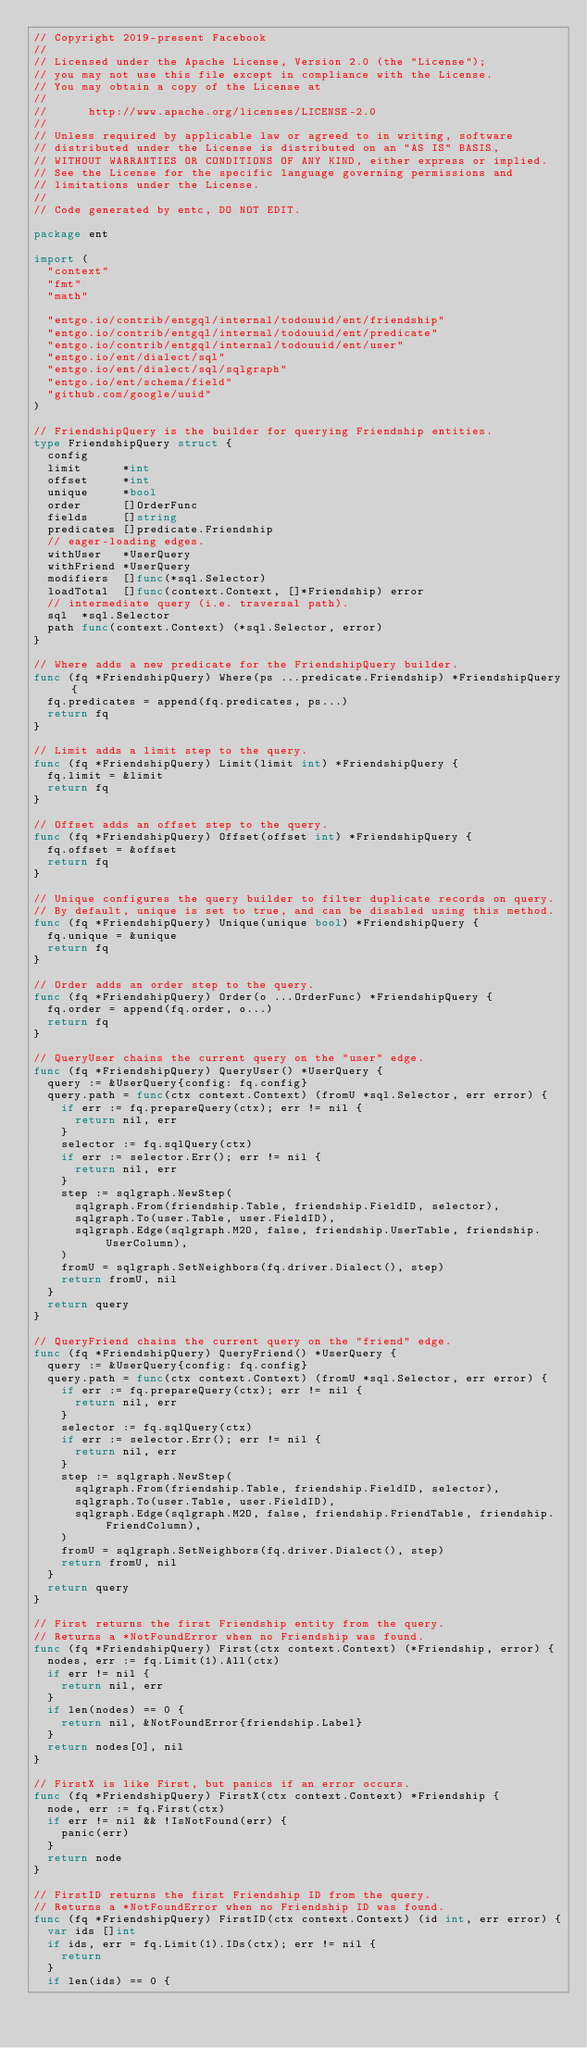Convert code to text. <code><loc_0><loc_0><loc_500><loc_500><_Go_>// Copyright 2019-present Facebook
//
// Licensed under the Apache License, Version 2.0 (the "License");
// you may not use this file except in compliance with the License.
// You may obtain a copy of the License at
//
//      http://www.apache.org/licenses/LICENSE-2.0
//
// Unless required by applicable law or agreed to in writing, software
// distributed under the License is distributed on an "AS IS" BASIS,
// WITHOUT WARRANTIES OR CONDITIONS OF ANY KIND, either express or implied.
// See the License for the specific language governing permissions and
// limitations under the License.
//
// Code generated by entc, DO NOT EDIT.

package ent

import (
	"context"
	"fmt"
	"math"

	"entgo.io/contrib/entgql/internal/todouuid/ent/friendship"
	"entgo.io/contrib/entgql/internal/todouuid/ent/predicate"
	"entgo.io/contrib/entgql/internal/todouuid/ent/user"
	"entgo.io/ent/dialect/sql"
	"entgo.io/ent/dialect/sql/sqlgraph"
	"entgo.io/ent/schema/field"
	"github.com/google/uuid"
)

// FriendshipQuery is the builder for querying Friendship entities.
type FriendshipQuery struct {
	config
	limit      *int
	offset     *int
	unique     *bool
	order      []OrderFunc
	fields     []string
	predicates []predicate.Friendship
	// eager-loading edges.
	withUser   *UserQuery
	withFriend *UserQuery
	modifiers  []func(*sql.Selector)
	loadTotal  []func(context.Context, []*Friendship) error
	// intermediate query (i.e. traversal path).
	sql  *sql.Selector
	path func(context.Context) (*sql.Selector, error)
}

// Where adds a new predicate for the FriendshipQuery builder.
func (fq *FriendshipQuery) Where(ps ...predicate.Friendship) *FriendshipQuery {
	fq.predicates = append(fq.predicates, ps...)
	return fq
}

// Limit adds a limit step to the query.
func (fq *FriendshipQuery) Limit(limit int) *FriendshipQuery {
	fq.limit = &limit
	return fq
}

// Offset adds an offset step to the query.
func (fq *FriendshipQuery) Offset(offset int) *FriendshipQuery {
	fq.offset = &offset
	return fq
}

// Unique configures the query builder to filter duplicate records on query.
// By default, unique is set to true, and can be disabled using this method.
func (fq *FriendshipQuery) Unique(unique bool) *FriendshipQuery {
	fq.unique = &unique
	return fq
}

// Order adds an order step to the query.
func (fq *FriendshipQuery) Order(o ...OrderFunc) *FriendshipQuery {
	fq.order = append(fq.order, o...)
	return fq
}

// QueryUser chains the current query on the "user" edge.
func (fq *FriendshipQuery) QueryUser() *UserQuery {
	query := &UserQuery{config: fq.config}
	query.path = func(ctx context.Context) (fromU *sql.Selector, err error) {
		if err := fq.prepareQuery(ctx); err != nil {
			return nil, err
		}
		selector := fq.sqlQuery(ctx)
		if err := selector.Err(); err != nil {
			return nil, err
		}
		step := sqlgraph.NewStep(
			sqlgraph.From(friendship.Table, friendship.FieldID, selector),
			sqlgraph.To(user.Table, user.FieldID),
			sqlgraph.Edge(sqlgraph.M2O, false, friendship.UserTable, friendship.UserColumn),
		)
		fromU = sqlgraph.SetNeighbors(fq.driver.Dialect(), step)
		return fromU, nil
	}
	return query
}

// QueryFriend chains the current query on the "friend" edge.
func (fq *FriendshipQuery) QueryFriend() *UserQuery {
	query := &UserQuery{config: fq.config}
	query.path = func(ctx context.Context) (fromU *sql.Selector, err error) {
		if err := fq.prepareQuery(ctx); err != nil {
			return nil, err
		}
		selector := fq.sqlQuery(ctx)
		if err := selector.Err(); err != nil {
			return nil, err
		}
		step := sqlgraph.NewStep(
			sqlgraph.From(friendship.Table, friendship.FieldID, selector),
			sqlgraph.To(user.Table, user.FieldID),
			sqlgraph.Edge(sqlgraph.M2O, false, friendship.FriendTable, friendship.FriendColumn),
		)
		fromU = sqlgraph.SetNeighbors(fq.driver.Dialect(), step)
		return fromU, nil
	}
	return query
}

// First returns the first Friendship entity from the query.
// Returns a *NotFoundError when no Friendship was found.
func (fq *FriendshipQuery) First(ctx context.Context) (*Friendship, error) {
	nodes, err := fq.Limit(1).All(ctx)
	if err != nil {
		return nil, err
	}
	if len(nodes) == 0 {
		return nil, &NotFoundError{friendship.Label}
	}
	return nodes[0], nil
}

// FirstX is like First, but panics if an error occurs.
func (fq *FriendshipQuery) FirstX(ctx context.Context) *Friendship {
	node, err := fq.First(ctx)
	if err != nil && !IsNotFound(err) {
		panic(err)
	}
	return node
}

// FirstID returns the first Friendship ID from the query.
// Returns a *NotFoundError when no Friendship ID was found.
func (fq *FriendshipQuery) FirstID(ctx context.Context) (id int, err error) {
	var ids []int
	if ids, err = fq.Limit(1).IDs(ctx); err != nil {
		return
	}
	if len(ids) == 0 {</code> 